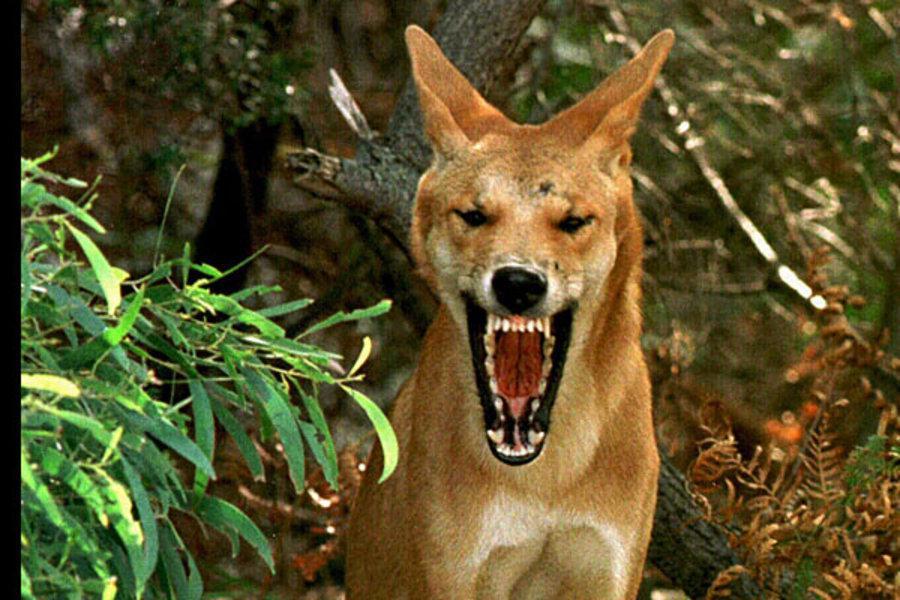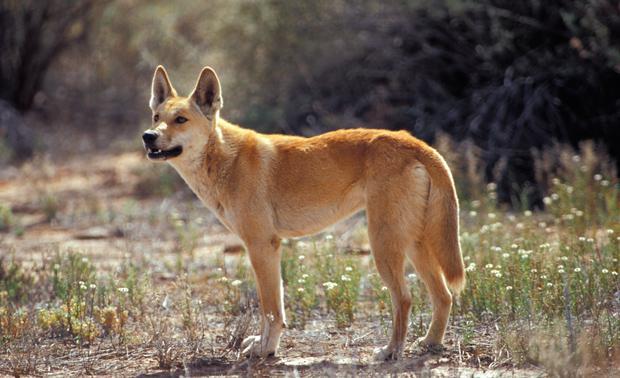The first image is the image on the left, the second image is the image on the right. For the images shown, is this caption "At least one dog has its teeth visible." true? Answer yes or no. Yes. 